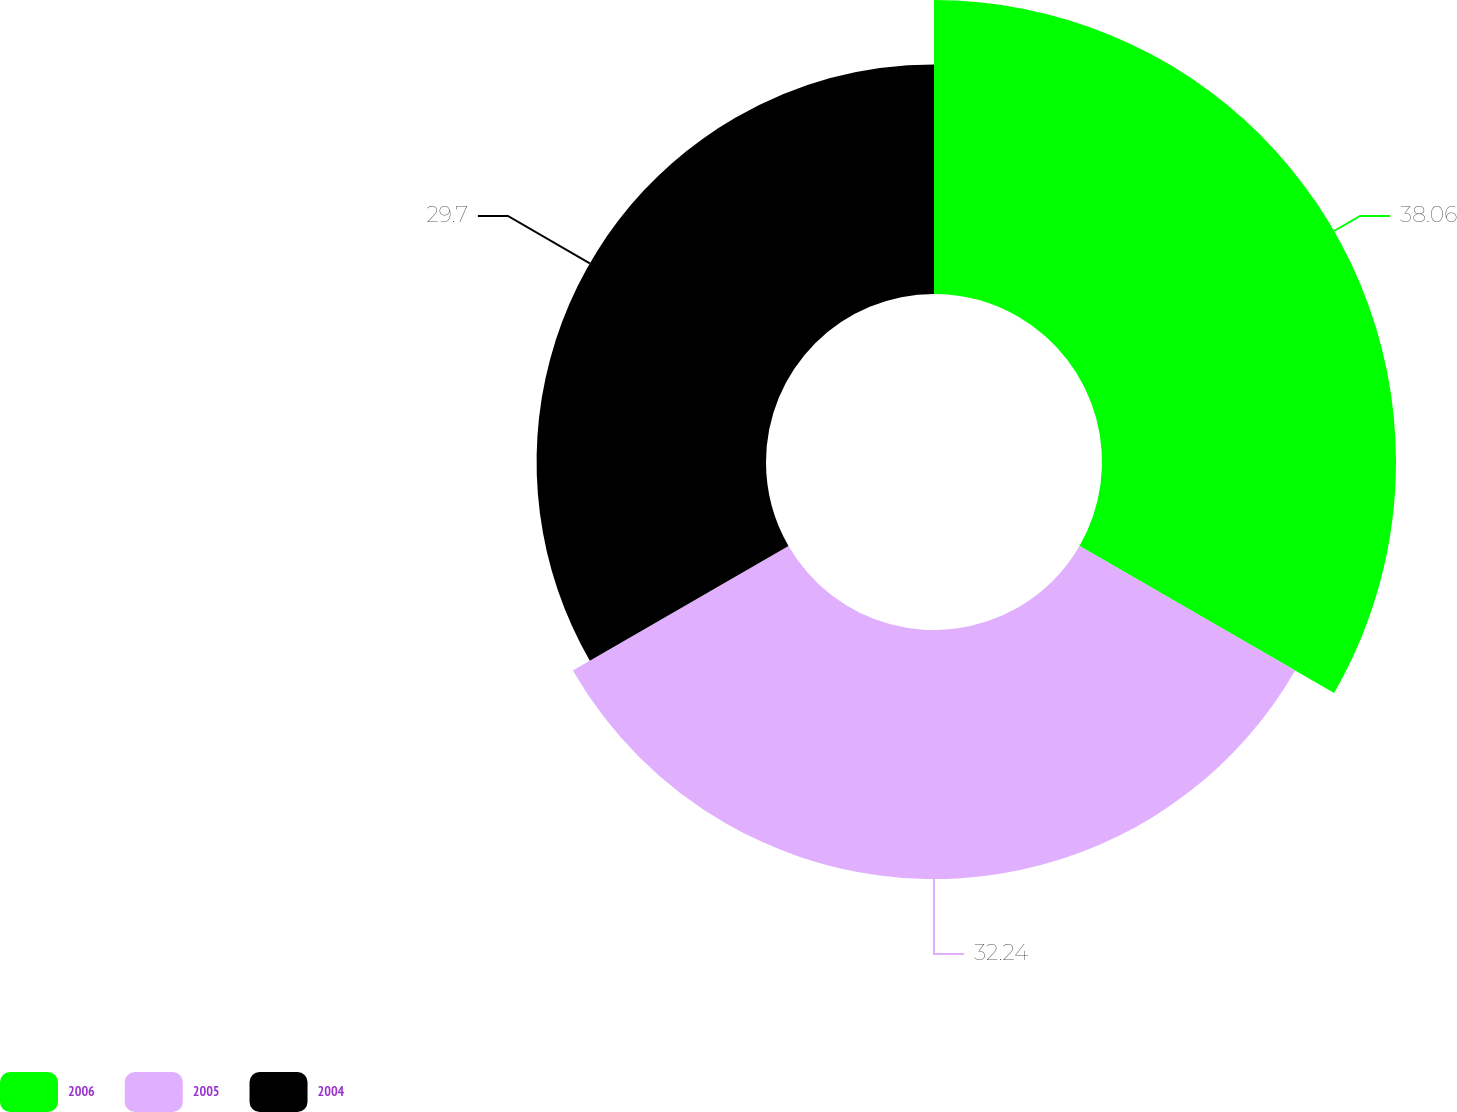Convert chart to OTSL. <chart><loc_0><loc_0><loc_500><loc_500><pie_chart><fcel>2006<fcel>2005<fcel>2004<nl><fcel>38.06%<fcel>32.24%<fcel>29.7%<nl></chart> 